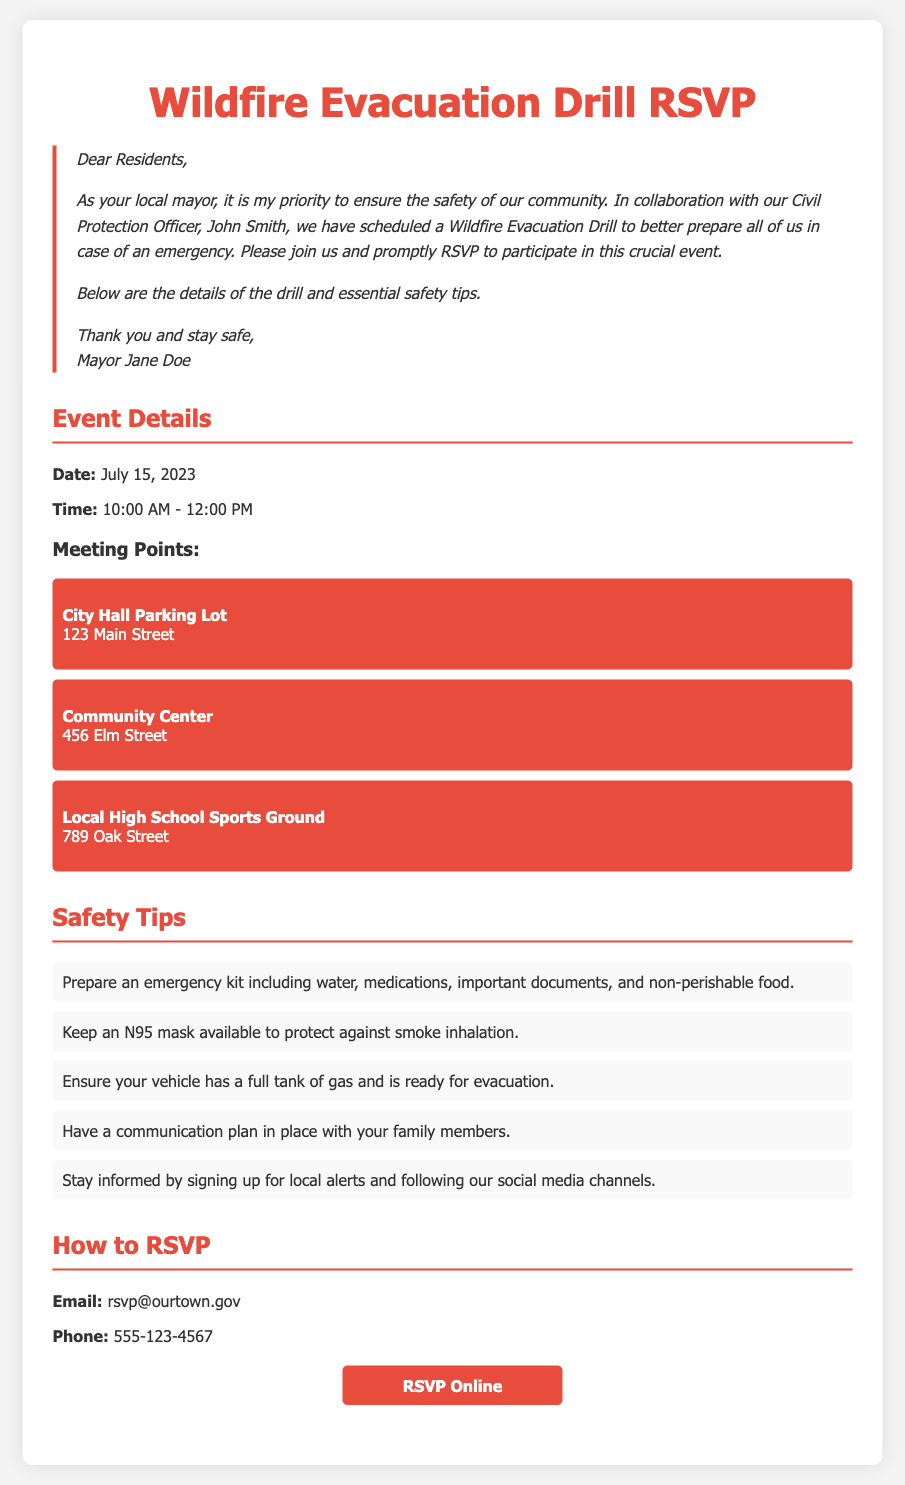What is the date of the drill? The date of the drill is mentioned clearly in the event details section.
Answer: July 15, 2023 What time does the drill start? The start time of the drill is specified in the event details section.
Answer: 10:00 AM Where is one of the meeting points located? Several meeting points are listed, any of which can be referenced from the document.
Answer: City Hall Parking Lot Who is the Civil Protection Officer? The document states the name of the Civil Protection Officer involved with the drill.
Answer: John Smith What should you prepare for the emergency kit? The safety tips provide specific items to include in the emergency kit.
Answer: Water, medications, important documents, non-perishable food How can residents RSVP? The RSVP instructions section outlines how residents can respond.
Answer: Email, phone, or online What color is the RSVP button? The document describes the appearance of the RSVP button, including its color.
Answer: Red Why is the drill scheduled? The document mentions a specific purpose for organizing the drill.
Answer: To better prepare in case of an emergency 